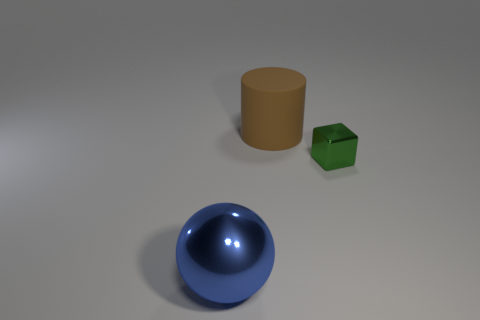Add 2 small cyan shiny things. How many objects exist? 5 Subtract all red cubes. Subtract all brown balls. How many cubes are left? 1 Add 2 brown cylinders. How many brown cylinders are left? 3 Add 1 green cubes. How many green cubes exist? 2 Subtract 0 purple blocks. How many objects are left? 3 Subtract all blocks. How many objects are left? 2 Subtract 1 cylinders. How many cylinders are left? 0 Subtract all tiny blue matte balls. Subtract all big cylinders. How many objects are left? 2 